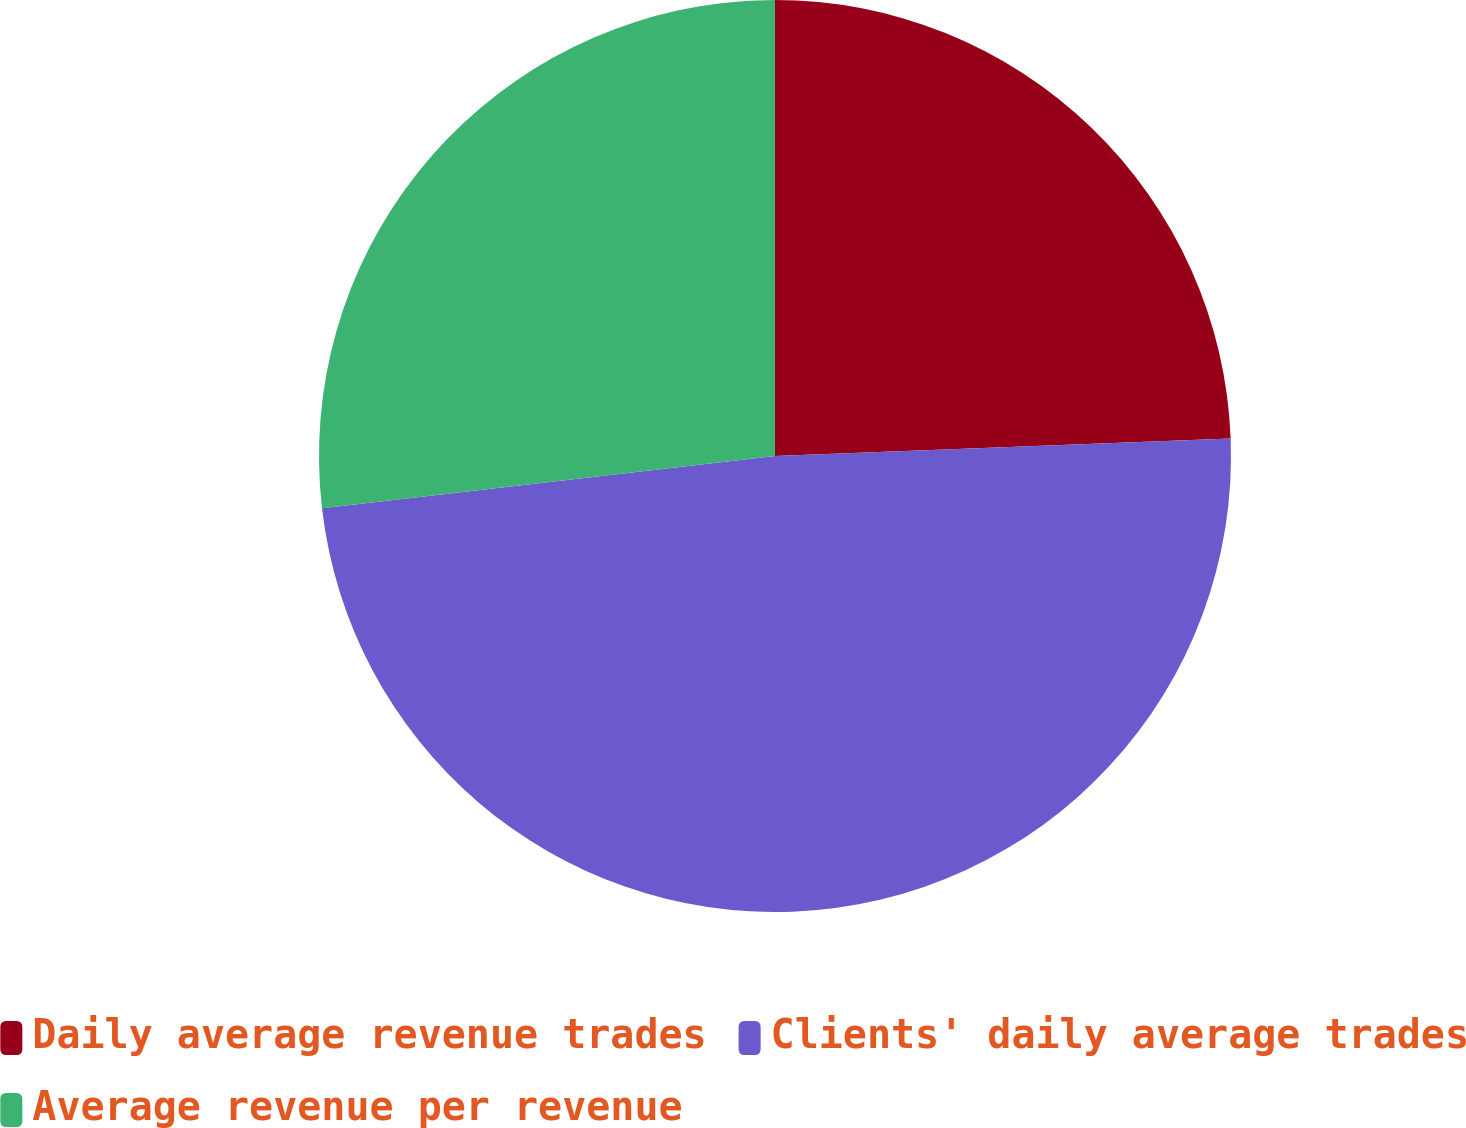<chart> <loc_0><loc_0><loc_500><loc_500><pie_chart><fcel>Daily average revenue trades<fcel>Clients' daily average trades<fcel>Average revenue per revenue<nl><fcel>24.39%<fcel>48.78%<fcel>26.83%<nl></chart> 